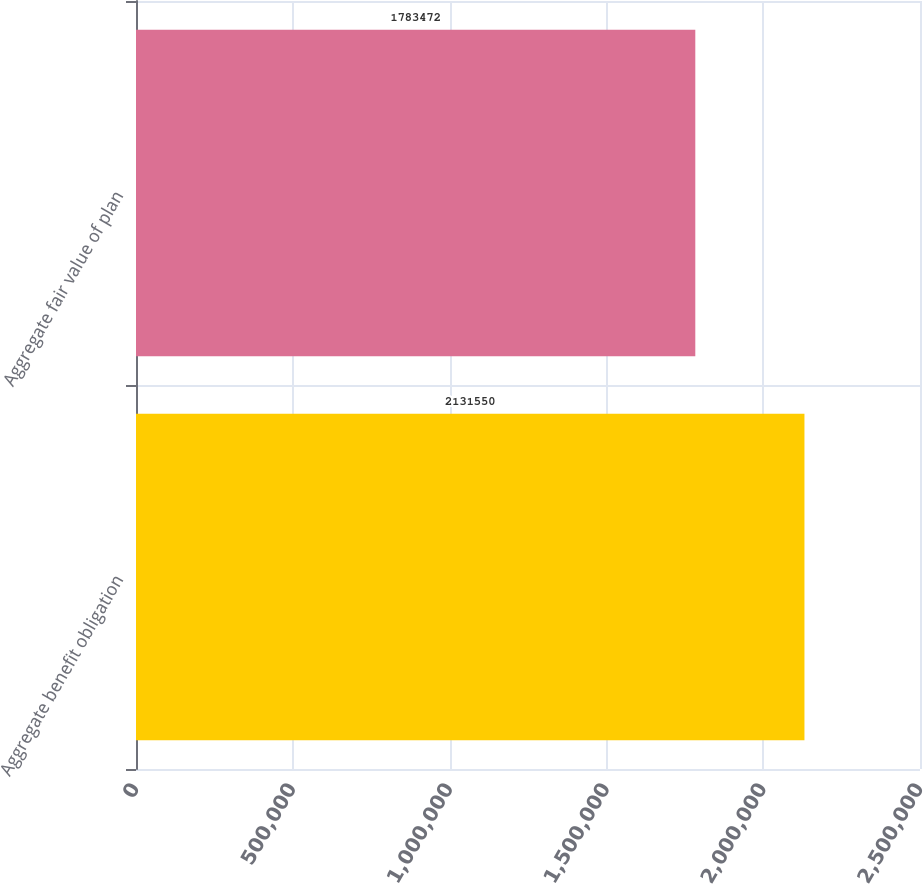<chart> <loc_0><loc_0><loc_500><loc_500><bar_chart><fcel>Aggregate benefit obligation<fcel>Aggregate fair value of plan<nl><fcel>2.13155e+06<fcel>1.78347e+06<nl></chart> 